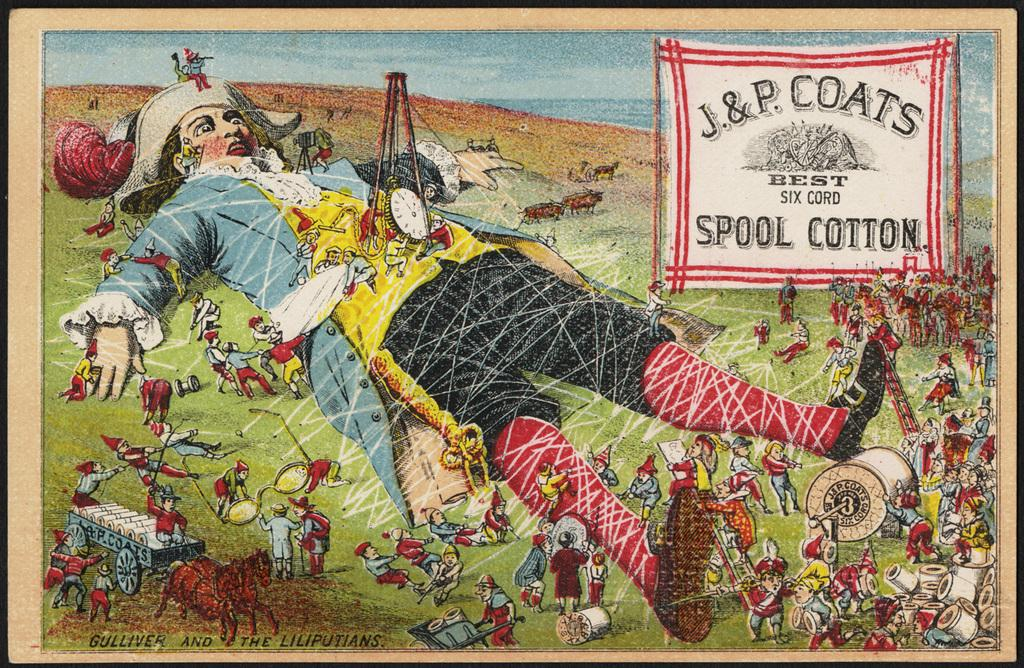<image>
Describe the image concisely. An advertisement for J. & P. Coats Spool Cotton depicting Gulliver being tied down by the Liliputians using the spool cotton. 